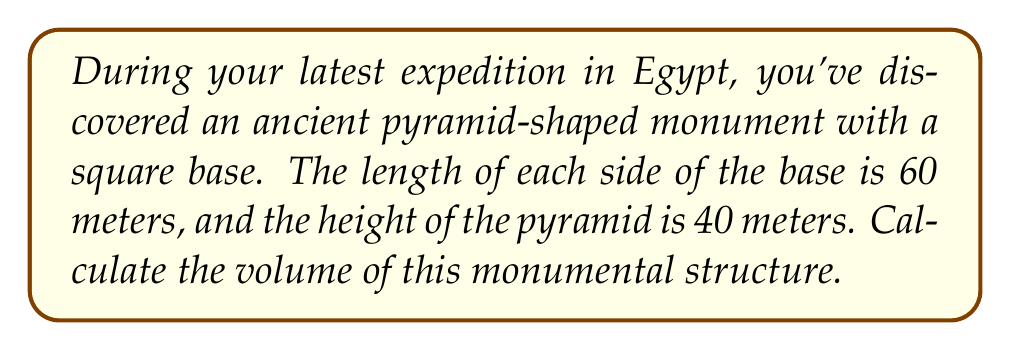Give your solution to this math problem. To calculate the volume of a pyramid, we use the formula:

$$V = \frac{1}{3} \times B \times h$$

Where:
$V$ = volume of the pyramid
$B$ = area of the base
$h$ = height of the pyramid

Let's solve this step-by-step:

1. Calculate the area of the base:
   The base is a square with side length 60 meters.
   $B = 60 \text{ m} \times 60 \text{ m} = 3600 \text{ m}^2$

2. We're given the height: $h = 40 \text{ m}$

3. Now, let's substitute these values into our volume formula:

   $$V = \frac{1}{3} \times 3600 \text{ m}^2 \times 40 \text{ m}$$

4. Simplify:
   $$V = \frac{1}{3} \times 144000 \text{ m}^3 = 48000 \text{ m}^3$$

Therefore, the volume of the pyramid-shaped monument is 48,000 cubic meters.

[asy]
import three;

size(200);
currentprojection=perspective(6,3,2);

triple A = (0,0,0), B = (60,0,0), C = (60,60,0), D = (0,60,0), E = (30,30,40);

draw(A--B--C--D--cycle);
draw(A--E--C,dashed);
draw(B--E--D,dashed);

label("60 m", (30,0,0), S);
label("60 m", (0,30,0), W);
label("40 m", (30,30,20), E);

dot(A); dot(B); dot(C); dot(D); dot(E);
[/asy]
Answer: The volume of the pyramid-shaped monument is 48,000 cubic meters. 